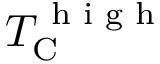<formula> <loc_0><loc_0><loc_500><loc_500>T _ { \mathrm C } ^ { h i g h }</formula> 